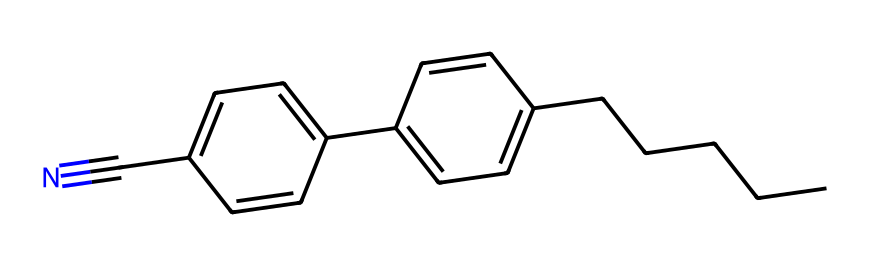What is the primary functional group present in this chemical? The triple bond between the nitrogen (N) and carbon (C) indicates the presence of a nitrile functional group, which characterizes the molecule.
Answer: nitrile How many rings are present in this structure? The structure contains two benzene rings that are clearly visible in the arrangement, confirming the presence of two rings.
Answer: 2 What type of intermolecular forces are likely to be present in this chemical? Due to the presence of polar nitrile groups and nonpolar hydrocarbon chains, dipole-dipole interactions and London dispersion forces will be at play in this chemical.
Answer: dipole-dipole and London dispersion forces How many carbon atoms are in this molecule? By counting the 'C' atoms from both the benzenes and the alkyl chain (CCCCC), there are 18 carbon atoms in total in the structure.
Answer: 18 What is the predominant phase of this chemical at room temperature? The structure has characteristics typical of liquid crystals, indicating it exists primarily as a liquid at room temperature, due to its unique molecular arrangement.
Answer: liquid What factors contribute to this compound's ability to organize into a liquid crystal? The elongated shape of the molecule, the presence of alignable functional groups, and the ability of the two aromatic rings to arrange themselves provide the necessary conditions for liquid crystalline behavior.
Answer: elongated shape and functional groups 